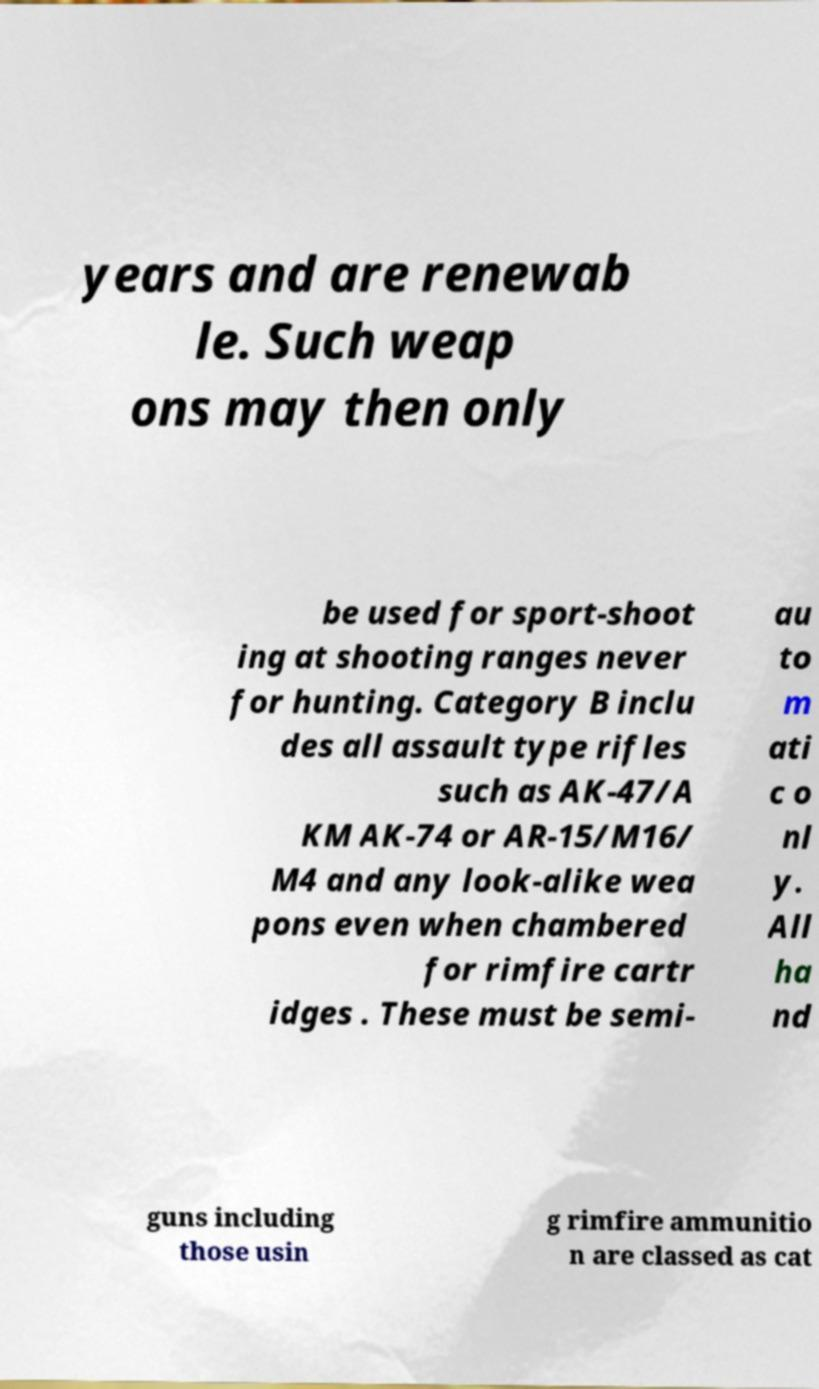Can you read and provide the text displayed in the image?This photo seems to have some interesting text. Can you extract and type it out for me? years and are renewab le. Such weap ons may then only be used for sport-shoot ing at shooting ranges never for hunting. Category B inclu des all assault type rifles such as AK-47/A KM AK-74 or AR-15/M16/ M4 and any look-alike wea pons even when chambered for rimfire cartr idges . These must be semi- au to m ati c o nl y. All ha nd guns including those usin g rimfire ammunitio n are classed as cat 